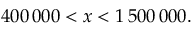<formula> <loc_0><loc_0><loc_500><loc_500>4 0 0 \, 0 0 0 < x < 1 \, 5 0 0 \, 0 0 0 .</formula> 